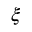Convert formula to latex. <formula><loc_0><loc_0><loc_500><loc_500>\xi</formula> 